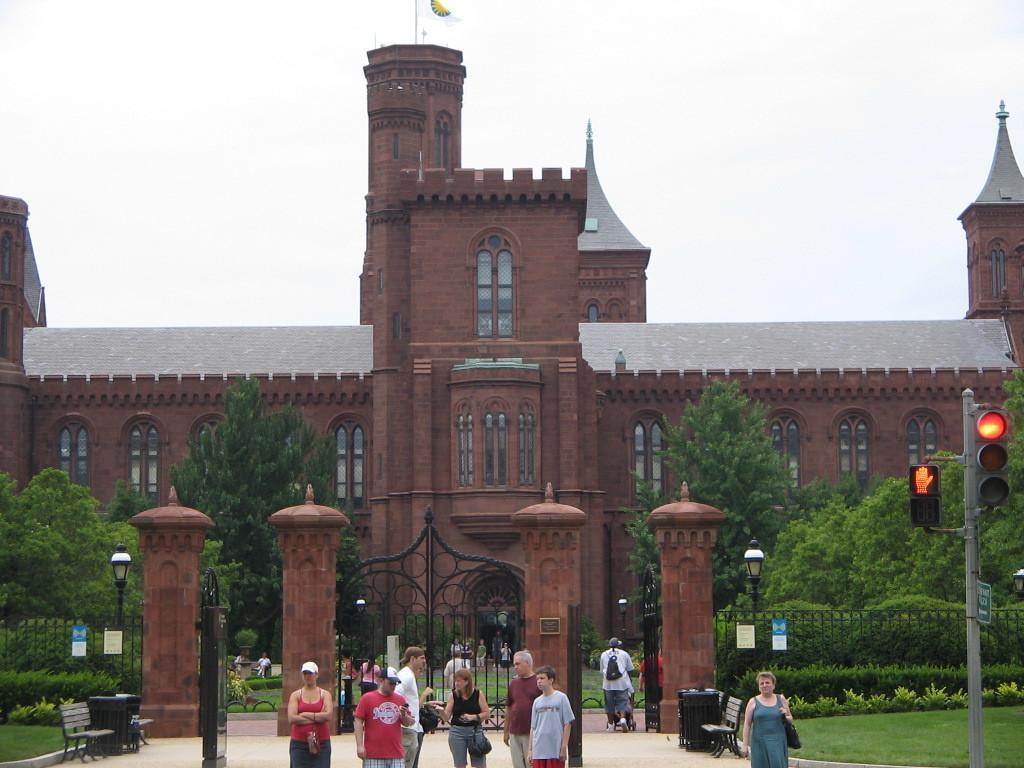Can you describe this image briefly? In this image I can see people standing. There is a traffic signal on the right. There are poles, a bench and gates. There are trees and a building at the back which has a flag at the top. 